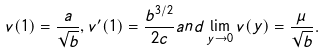<formula> <loc_0><loc_0><loc_500><loc_500>v ( 1 ) = \frac { a } { \sqrt { b } } , v ^ { \prime } ( 1 ) = \frac { b ^ { 3 / 2 } } { 2 c } a n d \lim _ { y \to 0 } v ( y ) = \frac { \mu } { \sqrt { b } } .</formula> 